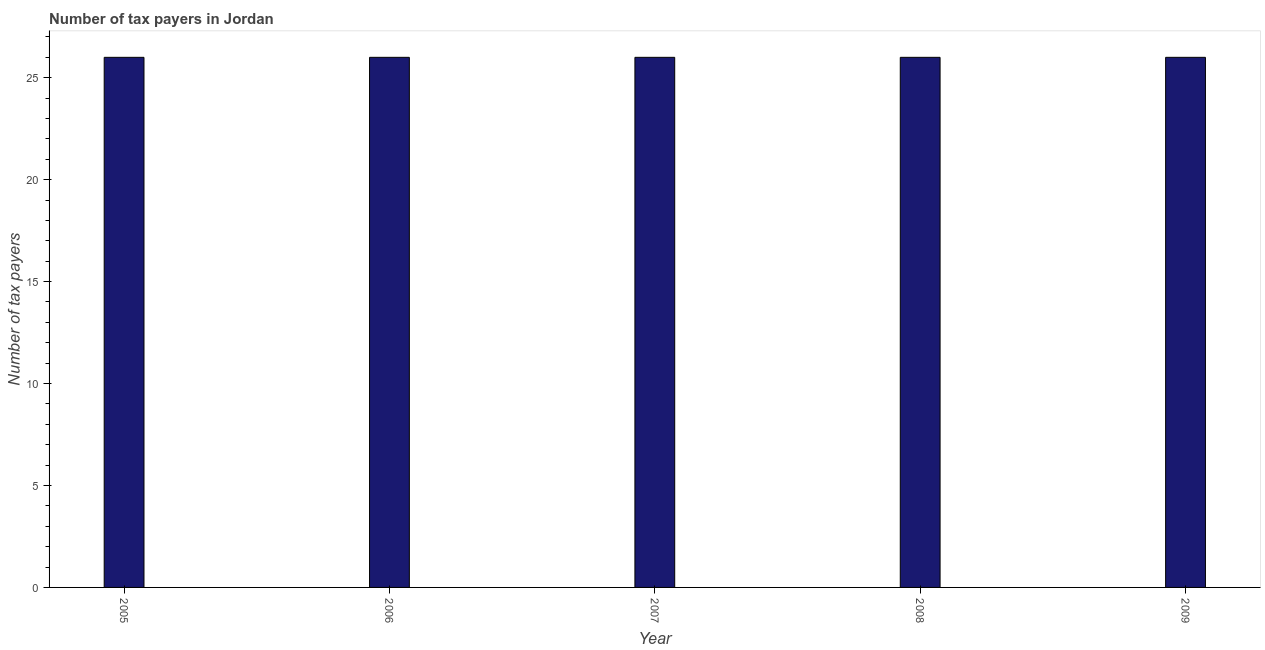Does the graph contain any zero values?
Provide a succinct answer. No. Does the graph contain grids?
Offer a terse response. No. What is the title of the graph?
Ensure brevity in your answer.  Number of tax payers in Jordan. What is the label or title of the X-axis?
Offer a very short reply. Year. What is the label or title of the Y-axis?
Offer a very short reply. Number of tax payers. What is the number of tax payers in 2006?
Provide a short and direct response. 26. In which year was the number of tax payers maximum?
Keep it short and to the point. 2005. In which year was the number of tax payers minimum?
Your response must be concise. 2005. What is the sum of the number of tax payers?
Ensure brevity in your answer.  130. What is the difference between the number of tax payers in 2006 and 2007?
Your answer should be compact. 0. What is the average number of tax payers per year?
Your response must be concise. 26. What is the ratio of the number of tax payers in 2007 to that in 2009?
Your answer should be very brief. 1. Is the difference between the number of tax payers in 2007 and 2008 greater than the difference between any two years?
Your answer should be very brief. Yes. What is the difference between the highest and the lowest number of tax payers?
Provide a succinct answer. 0. How many bars are there?
Ensure brevity in your answer.  5. Are all the bars in the graph horizontal?
Provide a short and direct response. No. Are the values on the major ticks of Y-axis written in scientific E-notation?
Give a very brief answer. No. What is the Number of tax payers in 2005?
Offer a very short reply. 26. What is the Number of tax payers in 2007?
Your response must be concise. 26. What is the Number of tax payers of 2008?
Offer a very short reply. 26. What is the difference between the Number of tax payers in 2006 and 2009?
Your answer should be very brief. 0. What is the difference between the Number of tax payers in 2008 and 2009?
Your answer should be compact. 0. What is the ratio of the Number of tax payers in 2005 to that in 2008?
Your answer should be very brief. 1. What is the ratio of the Number of tax payers in 2006 to that in 2007?
Your answer should be compact. 1. What is the ratio of the Number of tax payers in 2006 to that in 2009?
Provide a short and direct response. 1. 